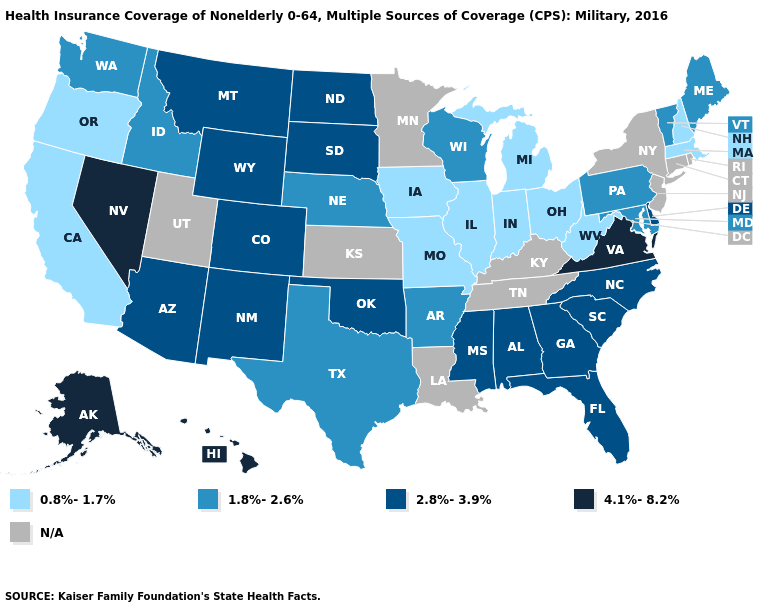Name the states that have a value in the range 2.8%-3.9%?
Quick response, please. Alabama, Arizona, Colorado, Delaware, Florida, Georgia, Mississippi, Montana, New Mexico, North Carolina, North Dakota, Oklahoma, South Carolina, South Dakota, Wyoming. Among the states that border Tennessee , which have the highest value?
Write a very short answer. Virginia. Name the states that have a value in the range 4.1%-8.2%?
Concise answer only. Alaska, Hawaii, Nevada, Virginia. What is the value of Ohio?
Quick response, please. 0.8%-1.7%. What is the value of Delaware?
Write a very short answer. 2.8%-3.9%. Among the states that border South Carolina , which have the highest value?
Give a very brief answer. Georgia, North Carolina. Name the states that have a value in the range 1.8%-2.6%?
Keep it brief. Arkansas, Idaho, Maine, Maryland, Nebraska, Pennsylvania, Texas, Vermont, Washington, Wisconsin. What is the value of West Virginia?
Write a very short answer. 0.8%-1.7%. Which states hav the highest value in the South?
Be succinct. Virginia. What is the value of Connecticut?
Answer briefly. N/A. Name the states that have a value in the range N/A?
Be succinct. Connecticut, Kansas, Kentucky, Louisiana, Minnesota, New Jersey, New York, Rhode Island, Tennessee, Utah. What is the value of Alabama?
Concise answer only. 2.8%-3.9%. Name the states that have a value in the range N/A?
Concise answer only. Connecticut, Kansas, Kentucky, Louisiana, Minnesota, New Jersey, New York, Rhode Island, Tennessee, Utah. Which states have the lowest value in the South?
Answer briefly. West Virginia. 